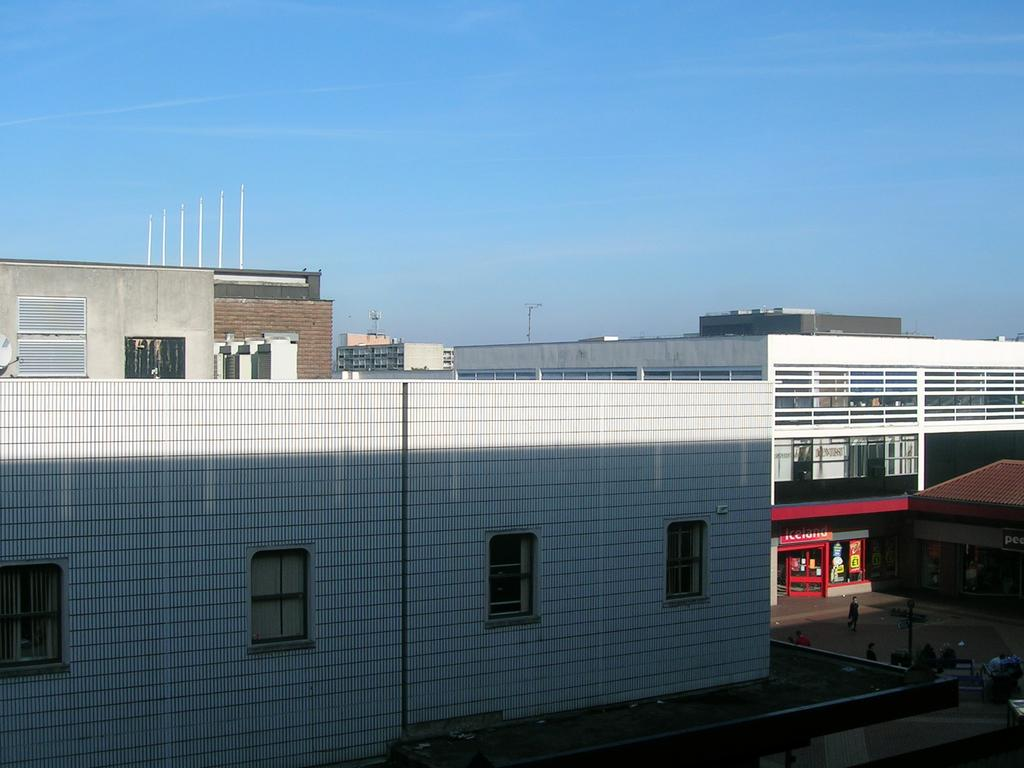What type of structures can be seen in the image? There are buildings in the image. What type of establishments can be found among the buildings? There are stores in the image. Can you describe the presence of people in the image? There are people visible between the buildings. What type of pain can be heard in the image? There is no audible pain present in the image; it is a visual representation of buildings, stores, and people. 